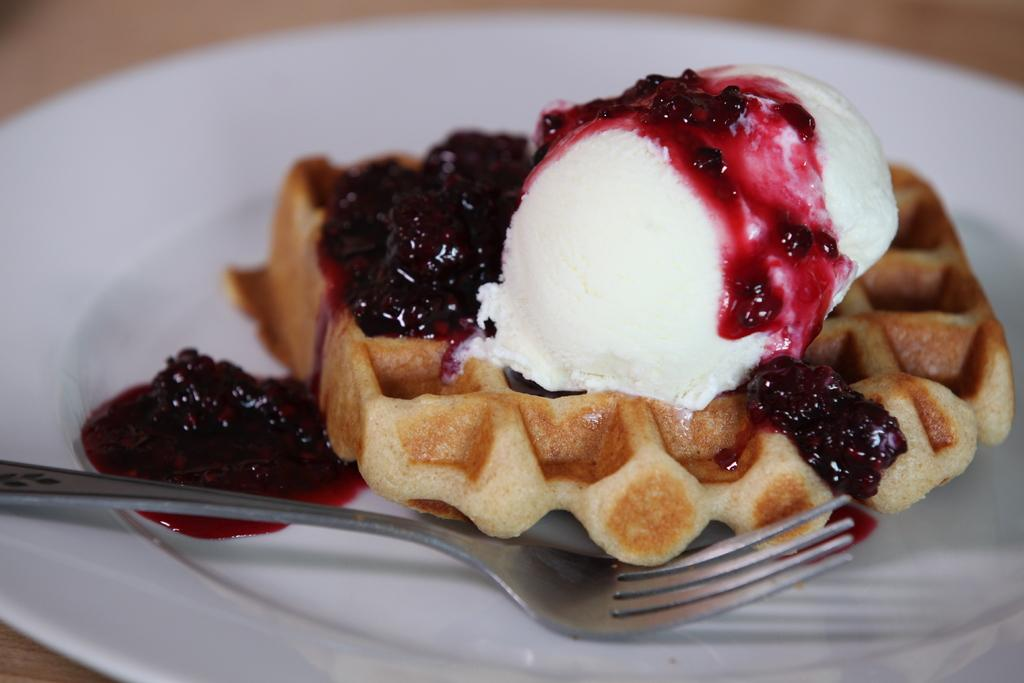What piece of furniture is present in the image? There is a table in the image. What is placed on the table? There is a plate on the table. What is on the plate? The plate contains food. What utensil is placed on the plate? There is a fork on the plate. What type of steel is used to make the plate in the image? There is no information about the material used to make the plate in the image. 